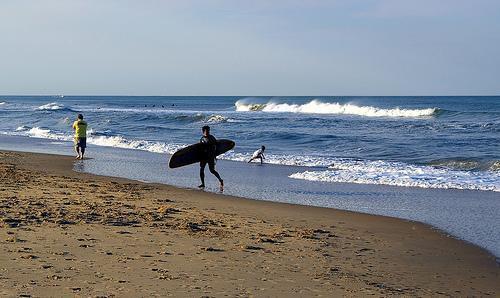Why is the small child in the water?
Answer the question by selecting the correct answer among the 4 following choices and explain your choice with a short sentence. The answer should be formatted with the following format: `Answer: choice
Rationale: rationale.`
Options: Enjoys playing, is lost, cleaning up, left home. Answer: enjoys playing.
Rationale: The child wants to play. 